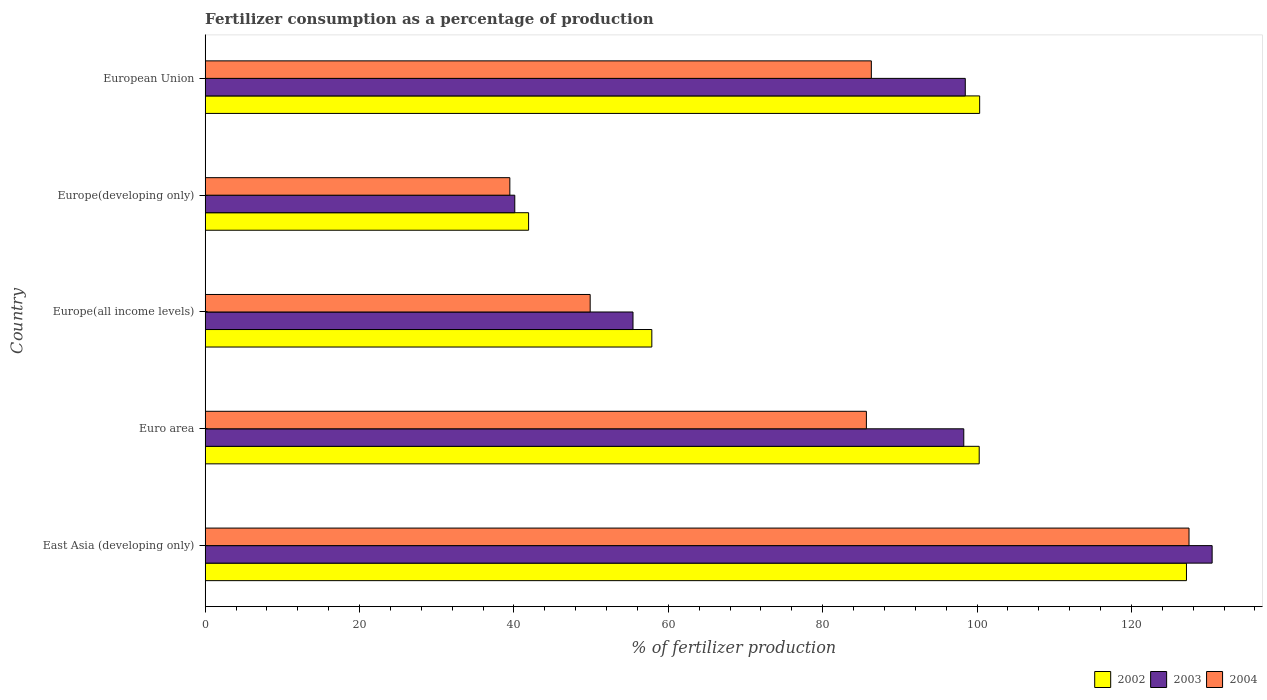How many different coloured bars are there?
Your answer should be very brief. 3. How many groups of bars are there?
Offer a terse response. 5. Are the number of bars per tick equal to the number of legend labels?
Your answer should be very brief. Yes. Are the number of bars on each tick of the Y-axis equal?
Offer a terse response. Yes. How many bars are there on the 5th tick from the top?
Offer a very short reply. 3. How many bars are there on the 2nd tick from the bottom?
Offer a terse response. 3. What is the label of the 5th group of bars from the top?
Keep it short and to the point. East Asia (developing only). What is the percentage of fertilizers consumed in 2004 in Europe(developing only)?
Ensure brevity in your answer.  39.47. Across all countries, what is the maximum percentage of fertilizers consumed in 2003?
Provide a succinct answer. 130.46. Across all countries, what is the minimum percentage of fertilizers consumed in 2004?
Make the answer very short. 39.47. In which country was the percentage of fertilizers consumed in 2004 maximum?
Your response must be concise. East Asia (developing only). In which country was the percentage of fertilizers consumed in 2003 minimum?
Provide a short and direct response. Europe(developing only). What is the total percentage of fertilizers consumed in 2004 in the graph?
Make the answer very short. 388.8. What is the difference between the percentage of fertilizers consumed in 2004 in Europe(developing only) and that in European Union?
Ensure brevity in your answer.  -46.84. What is the difference between the percentage of fertilizers consumed in 2003 in Euro area and the percentage of fertilizers consumed in 2004 in Europe(all income levels)?
Provide a succinct answer. 48.41. What is the average percentage of fertilizers consumed in 2004 per country?
Make the answer very short. 77.76. What is the difference between the percentage of fertilizers consumed in 2002 and percentage of fertilizers consumed in 2004 in Europe(developing only)?
Make the answer very short. 2.43. In how many countries, is the percentage of fertilizers consumed in 2002 greater than 4 %?
Provide a short and direct response. 5. What is the ratio of the percentage of fertilizers consumed in 2004 in Euro area to that in European Union?
Offer a terse response. 0.99. What is the difference between the highest and the second highest percentage of fertilizers consumed in 2003?
Ensure brevity in your answer.  31.99. What is the difference between the highest and the lowest percentage of fertilizers consumed in 2004?
Your response must be concise. 88. In how many countries, is the percentage of fertilizers consumed in 2004 greater than the average percentage of fertilizers consumed in 2004 taken over all countries?
Make the answer very short. 3. Is it the case that in every country, the sum of the percentage of fertilizers consumed in 2002 and percentage of fertilizers consumed in 2003 is greater than the percentage of fertilizers consumed in 2004?
Offer a terse response. Yes. How many countries are there in the graph?
Give a very brief answer. 5. What is the difference between two consecutive major ticks on the X-axis?
Provide a succinct answer. 20. Are the values on the major ticks of X-axis written in scientific E-notation?
Provide a succinct answer. No. Does the graph contain any zero values?
Provide a short and direct response. No. Does the graph contain grids?
Make the answer very short. No. Where does the legend appear in the graph?
Provide a short and direct response. Bottom right. How many legend labels are there?
Your answer should be very brief. 3. How are the legend labels stacked?
Keep it short and to the point. Horizontal. What is the title of the graph?
Offer a very short reply. Fertilizer consumption as a percentage of production. What is the label or title of the X-axis?
Offer a terse response. % of fertilizer production. What is the % of fertilizer production of 2002 in East Asia (developing only)?
Ensure brevity in your answer.  127.14. What is the % of fertilizer production of 2003 in East Asia (developing only)?
Make the answer very short. 130.46. What is the % of fertilizer production in 2004 in East Asia (developing only)?
Ensure brevity in your answer.  127.47. What is the % of fertilizer production of 2002 in Euro area?
Your answer should be very brief. 100.28. What is the % of fertilizer production in 2003 in Euro area?
Keep it short and to the point. 98.29. What is the % of fertilizer production of 2004 in Euro area?
Provide a short and direct response. 85.67. What is the % of fertilizer production in 2002 in Europe(all income levels)?
Your answer should be compact. 57.87. What is the % of fertilizer production in 2003 in Europe(all income levels)?
Your answer should be very brief. 55.43. What is the % of fertilizer production in 2004 in Europe(all income levels)?
Provide a short and direct response. 49.88. What is the % of fertilizer production of 2002 in Europe(developing only)?
Your answer should be very brief. 41.9. What is the % of fertilizer production in 2003 in Europe(developing only)?
Your answer should be very brief. 40.11. What is the % of fertilizer production of 2004 in Europe(developing only)?
Give a very brief answer. 39.47. What is the % of fertilizer production in 2002 in European Union?
Your answer should be very brief. 100.34. What is the % of fertilizer production in 2003 in European Union?
Offer a very short reply. 98.48. What is the % of fertilizer production in 2004 in European Union?
Keep it short and to the point. 86.31. Across all countries, what is the maximum % of fertilizer production in 2002?
Your response must be concise. 127.14. Across all countries, what is the maximum % of fertilizer production of 2003?
Your answer should be compact. 130.46. Across all countries, what is the maximum % of fertilizer production in 2004?
Make the answer very short. 127.47. Across all countries, what is the minimum % of fertilizer production of 2002?
Provide a succinct answer. 41.9. Across all countries, what is the minimum % of fertilizer production in 2003?
Make the answer very short. 40.11. Across all countries, what is the minimum % of fertilizer production of 2004?
Provide a short and direct response. 39.47. What is the total % of fertilizer production of 2002 in the graph?
Make the answer very short. 427.53. What is the total % of fertilizer production in 2003 in the graph?
Provide a succinct answer. 422.77. What is the total % of fertilizer production in 2004 in the graph?
Your answer should be very brief. 388.8. What is the difference between the % of fertilizer production in 2002 in East Asia (developing only) and that in Euro area?
Keep it short and to the point. 26.85. What is the difference between the % of fertilizer production in 2003 in East Asia (developing only) and that in Euro area?
Give a very brief answer. 32.18. What is the difference between the % of fertilizer production in 2004 in East Asia (developing only) and that in Euro area?
Provide a short and direct response. 41.8. What is the difference between the % of fertilizer production of 2002 in East Asia (developing only) and that in Europe(all income levels)?
Your response must be concise. 69.27. What is the difference between the % of fertilizer production in 2003 in East Asia (developing only) and that in Europe(all income levels)?
Provide a short and direct response. 75.04. What is the difference between the % of fertilizer production of 2004 in East Asia (developing only) and that in Europe(all income levels)?
Keep it short and to the point. 77.59. What is the difference between the % of fertilizer production in 2002 in East Asia (developing only) and that in Europe(developing only)?
Make the answer very short. 85.24. What is the difference between the % of fertilizer production in 2003 in East Asia (developing only) and that in Europe(developing only)?
Your response must be concise. 90.35. What is the difference between the % of fertilizer production of 2004 in East Asia (developing only) and that in Europe(developing only)?
Offer a terse response. 88. What is the difference between the % of fertilizer production of 2002 in East Asia (developing only) and that in European Union?
Make the answer very short. 26.79. What is the difference between the % of fertilizer production in 2003 in East Asia (developing only) and that in European Union?
Your answer should be compact. 31.99. What is the difference between the % of fertilizer production in 2004 in East Asia (developing only) and that in European Union?
Make the answer very short. 41.16. What is the difference between the % of fertilizer production of 2002 in Euro area and that in Europe(all income levels)?
Make the answer very short. 42.42. What is the difference between the % of fertilizer production in 2003 in Euro area and that in Europe(all income levels)?
Make the answer very short. 42.86. What is the difference between the % of fertilizer production of 2004 in Euro area and that in Europe(all income levels)?
Offer a very short reply. 35.79. What is the difference between the % of fertilizer production in 2002 in Euro area and that in Europe(developing only)?
Keep it short and to the point. 58.38. What is the difference between the % of fertilizer production of 2003 in Euro area and that in Europe(developing only)?
Offer a very short reply. 58.17. What is the difference between the % of fertilizer production in 2004 in Euro area and that in Europe(developing only)?
Provide a short and direct response. 46.2. What is the difference between the % of fertilizer production of 2002 in Euro area and that in European Union?
Ensure brevity in your answer.  -0.06. What is the difference between the % of fertilizer production of 2003 in Euro area and that in European Union?
Offer a terse response. -0.19. What is the difference between the % of fertilizer production of 2004 in Euro area and that in European Union?
Your answer should be very brief. -0.64. What is the difference between the % of fertilizer production in 2002 in Europe(all income levels) and that in Europe(developing only)?
Provide a short and direct response. 15.97. What is the difference between the % of fertilizer production in 2003 in Europe(all income levels) and that in Europe(developing only)?
Keep it short and to the point. 15.32. What is the difference between the % of fertilizer production of 2004 in Europe(all income levels) and that in Europe(developing only)?
Your answer should be compact. 10.41. What is the difference between the % of fertilizer production in 2002 in Europe(all income levels) and that in European Union?
Keep it short and to the point. -42.48. What is the difference between the % of fertilizer production of 2003 in Europe(all income levels) and that in European Union?
Provide a succinct answer. -43.05. What is the difference between the % of fertilizer production in 2004 in Europe(all income levels) and that in European Union?
Provide a short and direct response. -36.43. What is the difference between the % of fertilizer production of 2002 in Europe(developing only) and that in European Union?
Provide a short and direct response. -58.44. What is the difference between the % of fertilizer production in 2003 in Europe(developing only) and that in European Union?
Offer a very short reply. -58.37. What is the difference between the % of fertilizer production of 2004 in Europe(developing only) and that in European Union?
Your answer should be compact. -46.84. What is the difference between the % of fertilizer production of 2002 in East Asia (developing only) and the % of fertilizer production of 2003 in Euro area?
Provide a short and direct response. 28.85. What is the difference between the % of fertilizer production of 2002 in East Asia (developing only) and the % of fertilizer production of 2004 in Euro area?
Your response must be concise. 41.47. What is the difference between the % of fertilizer production of 2003 in East Asia (developing only) and the % of fertilizer production of 2004 in Euro area?
Give a very brief answer. 44.8. What is the difference between the % of fertilizer production in 2002 in East Asia (developing only) and the % of fertilizer production in 2003 in Europe(all income levels)?
Your answer should be very brief. 71.71. What is the difference between the % of fertilizer production of 2002 in East Asia (developing only) and the % of fertilizer production of 2004 in Europe(all income levels)?
Ensure brevity in your answer.  77.26. What is the difference between the % of fertilizer production in 2003 in East Asia (developing only) and the % of fertilizer production in 2004 in Europe(all income levels)?
Keep it short and to the point. 80.58. What is the difference between the % of fertilizer production of 2002 in East Asia (developing only) and the % of fertilizer production of 2003 in Europe(developing only)?
Make the answer very short. 87.03. What is the difference between the % of fertilizer production of 2002 in East Asia (developing only) and the % of fertilizer production of 2004 in Europe(developing only)?
Provide a short and direct response. 87.66. What is the difference between the % of fertilizer production of 2003 in East Asia (developing only) and the % of fertilizer production of 2004 in Europe(developing only)?
Give a very brief answer. 90.99. What is the difference between the % of fertilizer production of 2002 in East Asia (developing only) and the % of fertilizer production of 2003 in European Union?
Your response must be concise. 28.66. What is the difference between the % of fertilizer production in 2002 in East Asia (developing only) and the % of fertilizer production in 2004 in European Union?
Your answer should be compact. 40.83. What is the difference between the % of fertilizer production of 2003 in East Asia (developing only) and the % of fertilizer production of 2004 in European Union?
Provide a succinct answer. 44.16. What is the difference between the % of fertilizer production in 2002 in Euro area and the % of fertilizer production in 2003 in Europe(all income levels)?
Keep it short and to the point. 44.85. What is the difference between the % of fertilizer production in 2002 in Euro area and the % of fertilizer production in 2004 in Europe(all income levels)?
Offer a terse response. 50.4. What is the difference between the % of fertilizer production of 2003 in Euro area and the % of fertilizer production of 2004 in Europe(all income levels)?
Your answer should be compact. 48.41. What is the difference between the % of fertilizer production of 2002 in Euro area and the % of fertilizer production of 2003 in Europe(developing only)?
Your response must be concise. 60.17. What is the difference between the % of fertilizer production in 2002 in Euro area and the % of fertilizer production in 2004 in Europe(developing only)?
Keep it short and to the point. 60.81. What is the difference between the % of fertilizer production in 2003 in Euro area and the % of fertilizer production in 2004 in Europe(developing only)?
Offer a terse response. 58.81. What is the difference between the % of fertilizer production of 2002 in Euro area and the % of fertilizer production of 2003 in European Union?
Your answer should be compact. 1.8. What is the difference between the % of fertilizer production of 2002 in Euro area and the % of fertilizer production of 2004 in European Union?
Your response must be concise. 13.97. What is the difference between the % of fertilizer production in 2003 in Euro area and the % of fertilizer production in 2004 in European Union?
Provide a succinct answer. 11.98. What is the difference between the % of fertilizer production in 2002 in Europe(all income levels) and the % of fertilizer production in 2003 in Europe(developing only)?
Give a very brief answer. 17.76. What is the difference between the % of fertilizer production of 2002 in Europe(all income levels) and the % of fertilizer production of 2004 in Europe(developing only)?
Your answer should be very brief. 18.39. What is the difference between the % of fertilizer production of 2003 in Europe(all income levels) and the % of fertilizer production of 2004 in Europe(developing only)?
Provide a short and direct response. 15.96. What is the difference between the % of fertilizer production of 2002 in Europe(all income levels) and the % of fertilizer production of 2003 in European Union?
Make the answer very short. -40.61. What is the difference between the % of fertilizer production in 2002 in Europe(all income levels) and the % of fertilizer production in 2004 in European Union?
Give a very brief answer. -28.44. What is the difference between the % of fertilizer production in 2003 in Europe(all income levels) and the % of fertilizer production in 2004 in European Union?
Offer a very short reply. -30.88. What is the difference between the % of fertilizer production of 2002 in Europe(developing only) and the % of fertilizer production of 2003 in European Union?
Ensure brevity in your answer.  -56.58. What is the difference between the % of fertilizer production in 2002 in Europe(developing only) and the % of fertilizer production in 2004 in European Union?
Give a very brief answer. -44.41. What is the difference between the % of fertilizer production in 2003 in Europe(developing only) and the % of fertilizer production in 2004 in European Union?
Offer a terse response. -46.2. What is the average % of fertilizer production in 2002 per country?
Provide a succinct answer. 85.51. What is the average % of fertilizer production of 2003 per country?
Keep it short and to the point. 84.55. What is the average % of fertilizer production in 2004 per country?
Your answer should be very brief. 77.76. What is the difference between the % of fertilizer production in 2002 and % of fertilizer production in 2003 in East Asia (developing only)?
Your answer should be very brief. -3.33. What is the difference between the % of fertilizer production in 2002 and % of fertilizer production in 2004 in East Asia (developing only)?
Offer a terse response. -0.33. What is the difference between the % of fertilizer production in 2003 and % of fertilizer production in 2004 in East Asia (developing only)?
Make the answer very short. 3. What is the difference between the % of fertilizer production of 2002 and % of fertilizer production of 2003 in Euro area?
Offer a very short reply. 2. What is the difference between the % of fertilizer production of 2002 and % of fertilizer production of 2004 in Euro area?
Keep it short and to the point. 14.61. What is the difference between the % of fertilizer production of 2003 and % of fertilizer production of 2004 in Euro area?
Keep it short and to the point. 12.62. What is the difference between the % of fertilizer production of 2002 and % of fertilizer production of 2003 in Europe(all income levels)?
Your answer should be compact. 2.44. What is the difference between the % of fertilizer production in 2002 and % of fertilizer production in 2004 in Europe(all income levels)?
Make the answer very short. 7.99. What is the difference between the % of fertilizer production of 2003 and % of fertilizer production of 2004 in Europe(all income levels)?
Provide a succinct answer. 5.55. What is the difference between the % of fertilizer production in 2002 and % of fertilizer production in 2003 in Europe(developing only)?
Your response must be concise. 1.79. What is the difference between the % of fertilizer production of 2002 and % of fertilizer production of 2004 in Europe(developing only)?
Keep it short and to the point. 2.43. What is the difference between the % of fertilizer production of 2003 and % of fertilizer production of 2004 in Europe(developing only)?
Your answer should be compact. 0.64. What is the difference between the % of fertilizer production in 2002 and % of fertilizer production in 2003 in European Union?
Your answer should be compact. 1.86. What is the difference between the % of fertilizer production in 2002 and % of fertilizer production in 2004 in European Union?
Keep it short and to the point. 14.03. What is the difference between the % of fertilizer production in 2003 and % of fertilizer production in 2004 in European Union?
Give a very brief answer. 12.17. What is the ratio of the % of fertilizer production in 2002 in East Asia (developing only) to that in Euro area?
Make the answer very short. 1.27. What is the ratio of the % of fertilizer production in 2003 in East Asia (developing only) to that in Euro area?
Make the answer very short. 1.33. What is the ratio of the % of fertilizer production of 2004 in East Asia (developing only) to that in Euro area?
Your answer should be very brief. 1.49. What is the ratio of the % of fertilizer production of 2002 in East Asia (developing only) to that in Europe(all income levels)?
Your response must be concise. 2.2. What is the ratio of the % of fertilizer production of 2003 in East Asia (developing only) to that in Europe(all income levels)?
Offer a terse response. 2.35. What is the ratio of the % of fertilizer production in 2004 in East Asia (developing only) to that in Europe(all income levels)?
Make the answer very short. 2.56. What is the ratio of the % of fertilizer production in 2002 in East Asia (developing only) to that in Europe(developing only)?
Give a very brief answer. 3.03. What is the ratio of the % of fertilizer production of 2003 in East Asia (developing only) to that in Europe(developing only)?
Your answer should be very brief. 3.25. What is the ratio of the % of fertilizer production of 2004 in East Asia (developing only) to that in Europe(developing only)?
Ensure brevity in your answer.  3.23. What is the ratio of the % of fertilizer production of 2002 in East Asia (developing only) to that in European Union?
Offer a terse response. 1.27. What is the ratio of the % of fertilizer production in 2003 in East Asia (developing only) to that in European Union?
Offer a very short reply. 1.32. What is the ratio of the % of fertilizer production in 2004 in East Asia (developing only) to that in European Union?
Provide a short and direct response. 1.48. What is the ratio of the % of fertilizer production in 2002 in Euro area to that in Europe(all income levels)?
Offer a terse response. 1.73. What is the ratio of the % of fertilizer production in 2003 in Euro area to that in Europe(all income levels)?
Your answer should be compact. 1.77. What is the ratio of the % of fertilizer production in 2004 in Euro area to that in Europe(all income levels)?
Provide a succinct answer. 1.72. What is the ratio of the % of fertilizer production in 2002 in Euro area to that in Europe(developing only)?
Provide a short and direct response. 2.39. What is the ratio of the % of fertilizer production in 2003 in Euro area to that in Europe(developing only)?
Offer a very short reply. 2.45. What is the ratio of the % of fertilizer production in 2004 in Euro area to that in Europe(developing only)?
Make the answer very short. 2.17. What is the ratio of the % of fertilizer production of 2002 in Euro area to that in European Union?
Ensure brevity in your answer.  1. What is the ratio of the % of fertilizer production in 2002 in Europe(all income levels) to that in Europe(developing only)?
Offer a terse response. 1.38. What is the ratio of the % of fertilizer production in 2003 in Europe(all income levels) to that in Europe(developing only)?
Offer a very short reply. 1.38. What is the ratio of the % of fertilizer production of 2004 in Europe(all income levels) to that in Europe(developing only)?
Keep it short and to the point. 1.26. What is the ratio of the % of fertilizer production of 2002 in Europe(all income levels) to that in European Union?
Ensure brevity in your answer.  0.58. What is the ratio of the % of fertilizer production of 2003 in Europe(all income levels) to that in European Union?
Ensure brevity in your answer.  0.56. What is the ratio of the % of fertilizer production of 2004 in Europe(all income levels) to that in European Union?
Make the answer very short. 0.58. What is the ratio of the % of fertilizer production in 2002 in Europe(developing only) to that in European Union?
Your response must be concise. 0.42. What is the ratio of the % of fertilizer production of 2003 in Europe(developing only) to that in European Union?
Offer a very short reply. 0.41. What is the ratio of the % of fertilizer production of 2004 in Europe(developing only) to that in European Union?
Provide a succinct answer. 0.46. What is the difference between the highest and the second highest % of fertilizer production in 2002?
Make the answer very short. 26.79. What is the difference between the highest and the second highest % of fertilizer production of 2003?
Provide a succinct answer. 31.99. What is the difference between the highest and the second highest % of fertilizer production in 2004?
Ensure brevity in your answer.  41.16. What is the difference between the highest and the lowest % of fertilizer production of 2002?
Your answer should be very brief. 85.24. What is the difference between the highest and the lowest % of fertilizer production in 2003?
Provide a succinct answer. 90.35. What is the difference between the highest and the lowest % of fertilizer production in 2004?
Your answer should be compact. 88. 